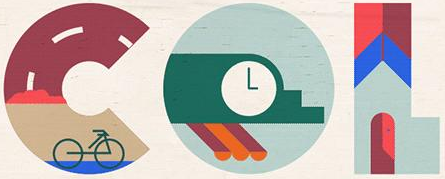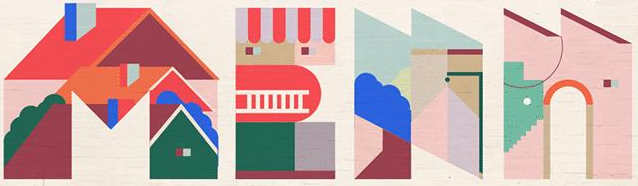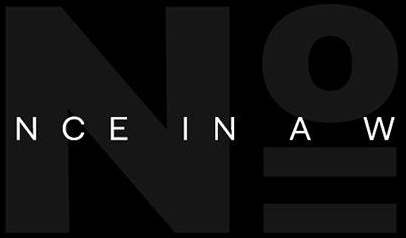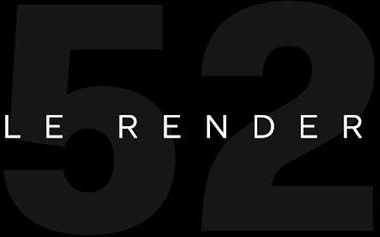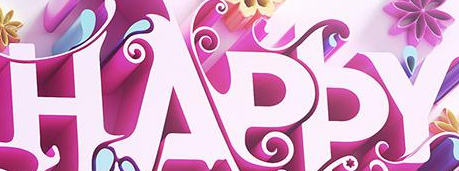Read the text from these images in sequence, separated by a semicolon. COL; MEAN; No; 52; HAPPY 